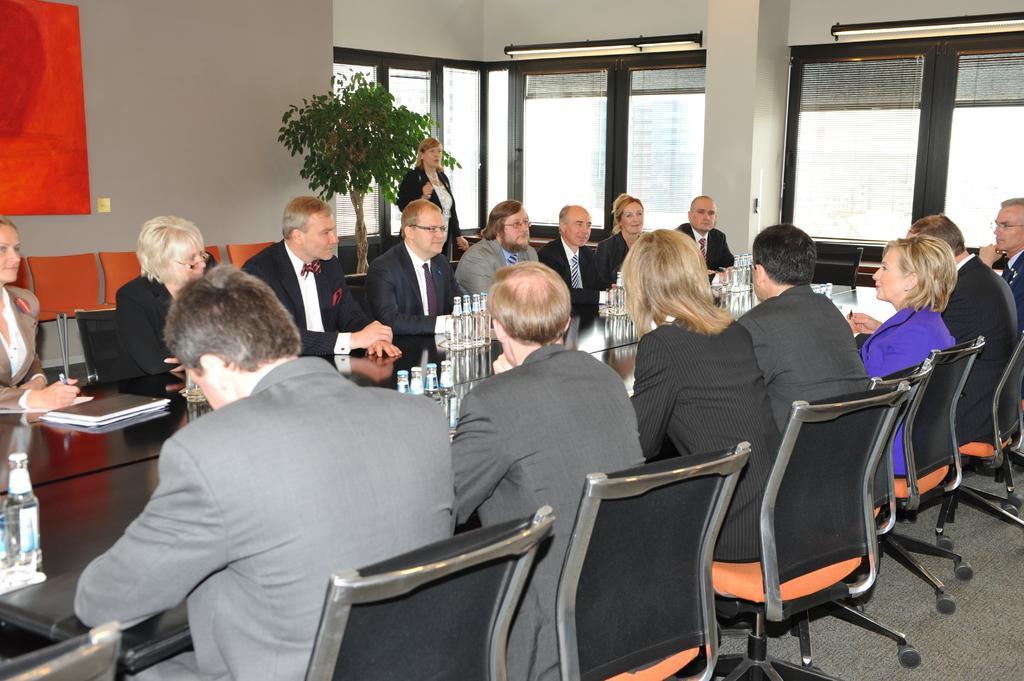Please provide a concise description of this image. In the image we can see the group of people were sitting in front of table. And coming to the background we can see the wall,plant and one lady is standing. 